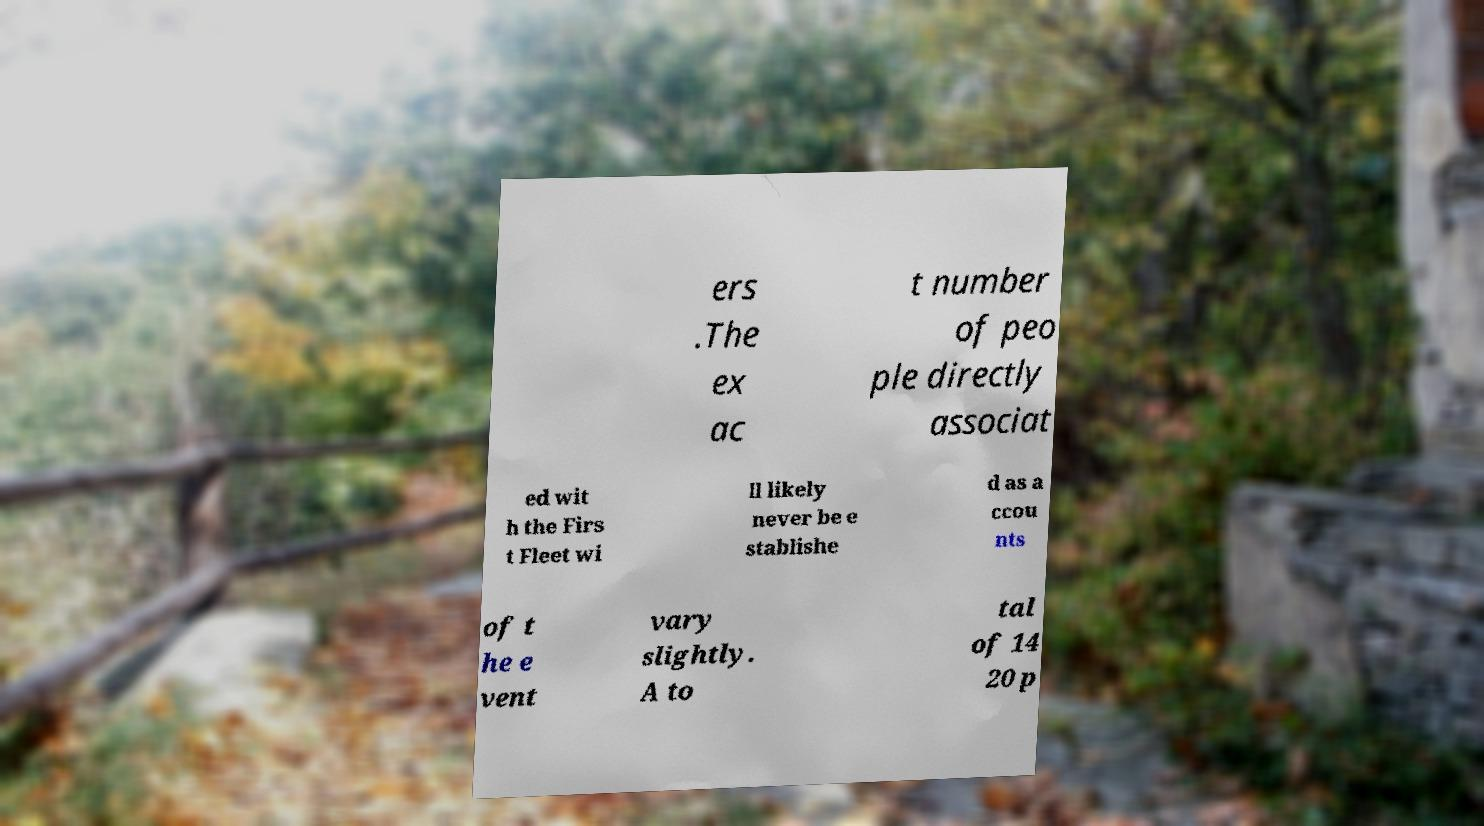Could you assist in decoding the text presented in this image and type it out clearly? ers .The ex ac t number of peo ple directly associat ed wit h the Firs t Fleet wi ll likely never be e stablishe d as a ccou nts of t he e vent vary slightly. A to tal of 14 20 p 